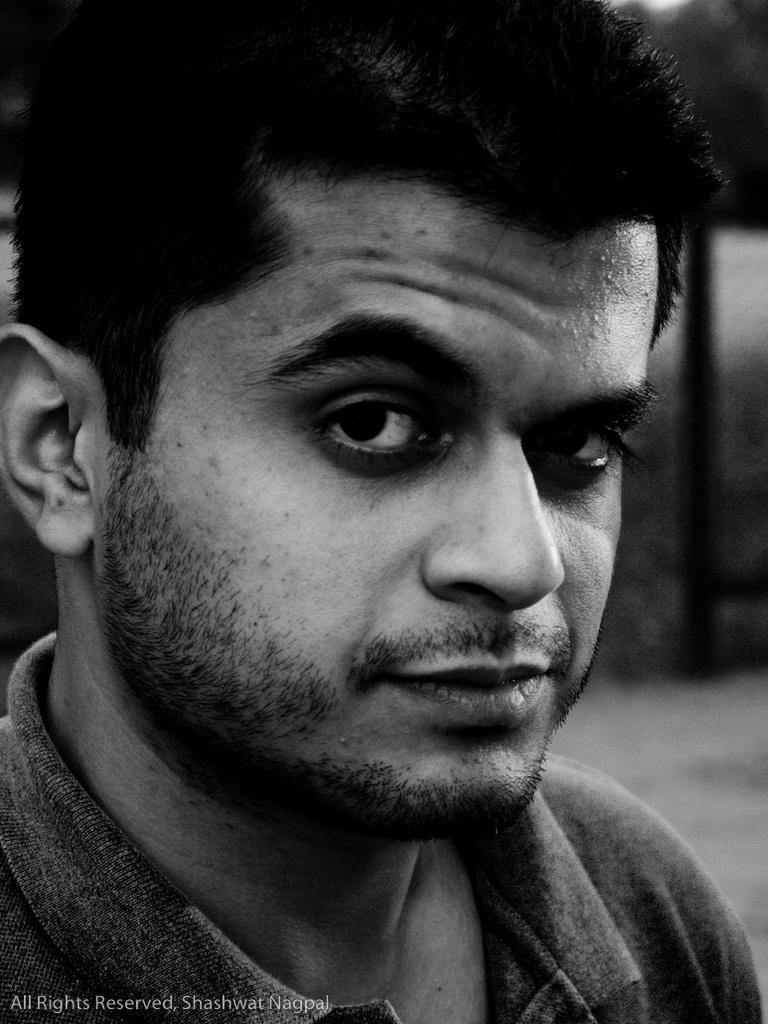In one or two sentences, can you explain what this image depicts? This is a black and white picture. The man in the front of the picture wearing t-shirt is looking at the camera. In the background, there are trees and it is blurred, in the background. 